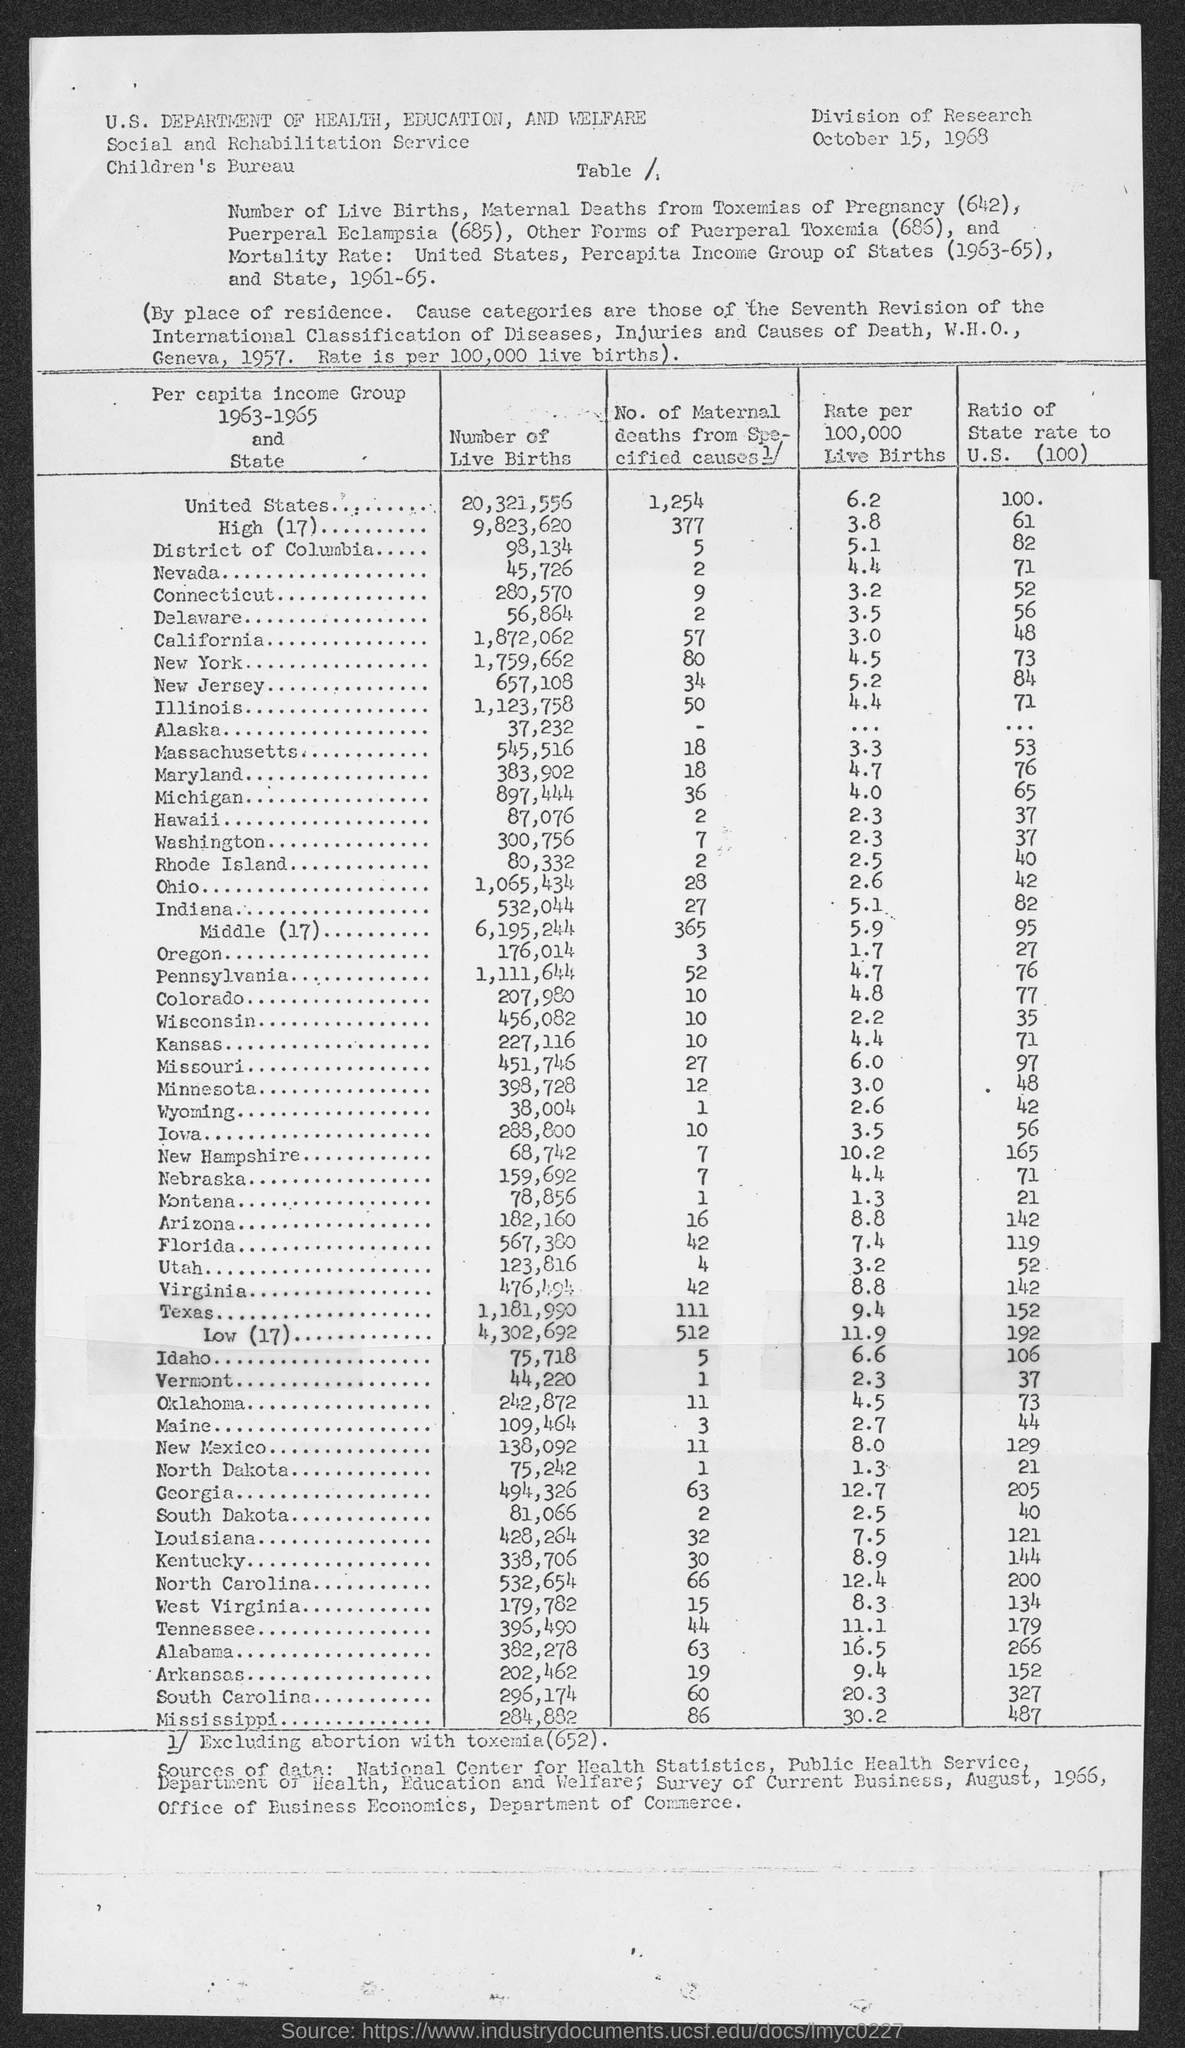What is the ratio of state rate to u.s (100) in district of columbia ?
Provide a short and direct response. 82. What is the ratio of state rate to u.s (100) in nevada ?
Make the answer very short. 71. What is the ratio of state rate to u.s (100) in connecticut?
Your answer should be compact. 52. What is the ratio of state rate to u.s (100) in delaware ?
Make the answer very short. 56. What is the ratio of state rate to u.s (100) in california?
Ensure brevity in your answer.  48. What is the ratio of state rate to u.s (100) in new york ?
Keep it short and to the point. 73. What is the ratio of state rate to u.s (100) in new jersey?
Ensure brevity in your answer.  84. What is the ratio of state rate to u.s (100) in illinois ?
Your answer should be very brief. 71. What is the ratio of state rate to u.s (100) in massachusetts ?
Your response must be concise. 53. What is the ratio of state rate to u.s (100) in maryland ?
Offer a very short reply. 76. 